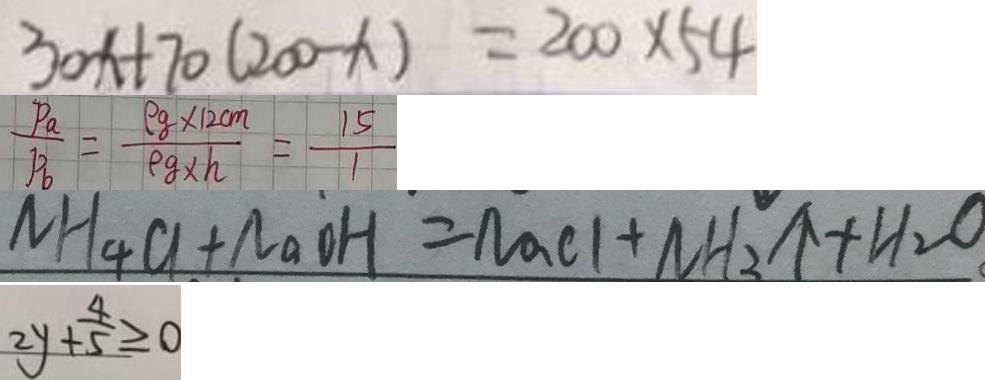<formula> <loc_0><loc_0><loc_500><loc_500>3 0 x + 7 0 ( 2 0 0 - x ) = 2 0 0 \times 5 4 
 \frac { P _ { a } } { F _ { 6 } } = \frac { \rho g \times 1 2 c m } { \rho g \times h } = \frac { 1 5 } { 1 } 
 N H _ { 4 } C l + N a O H = N a C l + N H _ { 3 } \uparrow + H _ { 2 } O 
 2 y + \frac { 4 } { 5 } \geq 0</formula> 